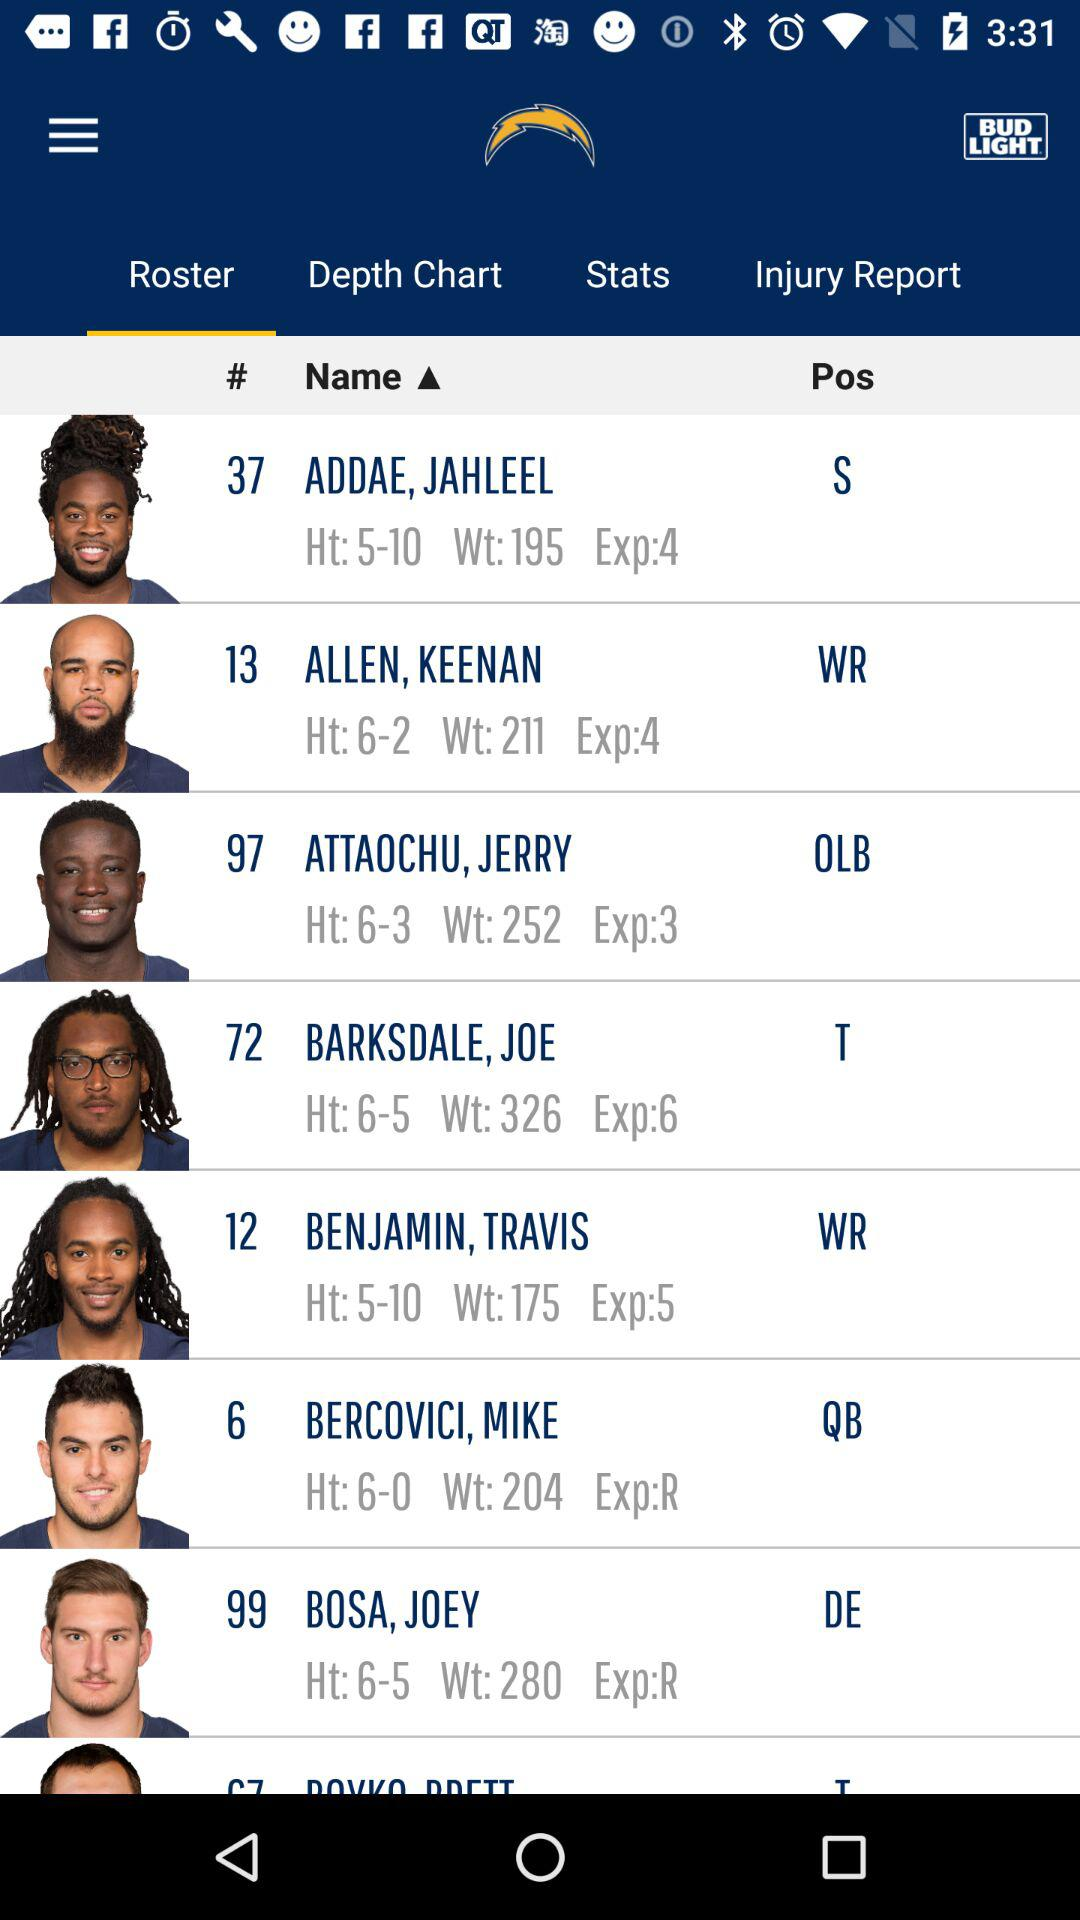Which player is 6-5 in height? The players are Joe Barksdale and Joey Bosa. 